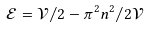Convert formula to latex. <formula><loc_0><loc_0><loc_500><loc_500>\mathcal { E } = \mathcal { V } / 2 - \pi ^ { 2 } n ^ { 2 } / 2 \mathcal { V }</formula> 